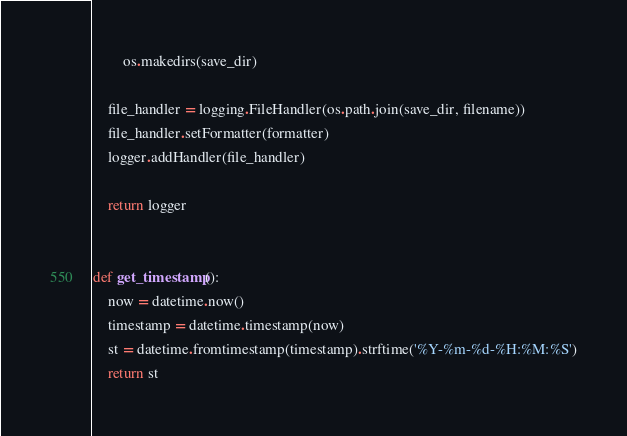Convert code to text. <code><loc_0><loc_0><loc_500><loc_500><_Python_>		os.makedirs(save_dir)

	file_handler = logging.FileHandler(os.path.join(save_dir, filename))
	file_handler.setFormatter(formatter)
	logger.addHandler(file_handler)

	return logger


def get_timestamp():
	now = datetime.now()
	timestamp = datetime.timestamp(now)
	st = datetime.fromtimestamp(timestamp).strftime('%Y-%m-%d-%H:%M:%S')
	return st</code> 